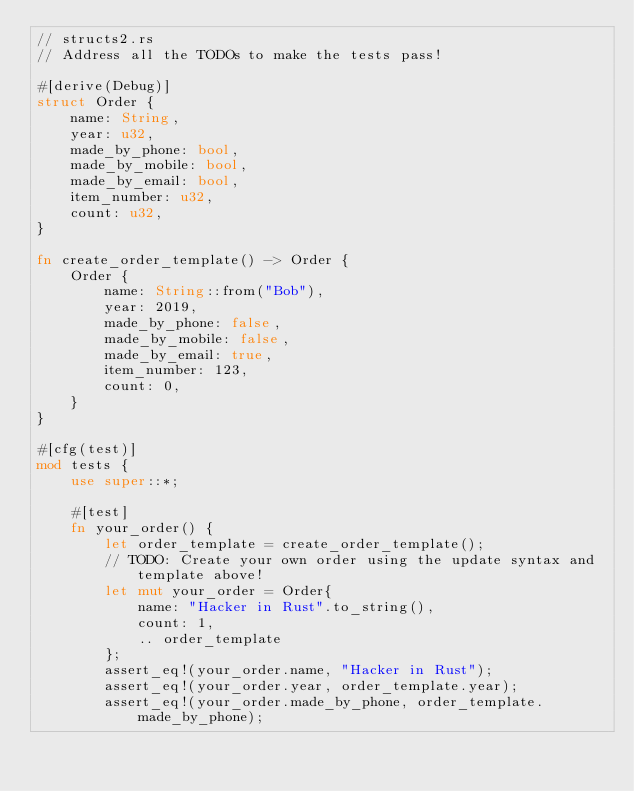<code> <loc_0><loc_0><loc_500><loc_500><_Rust_>// structs2.rs
// Address all the TODOs to make the tests pass!

#[derive(Debug)]
struct Order {
    name: String,
    year: u32,
    made_by_phone: bool,
    made_by_mobile: bool,
    made_by_email: bool,
    item_number: u32,
    count: u32,
}

fn create_order_template() -> Order {
    Order {
        name: String::from("Bob"),
        year: 2019,
        made_by_phone: false,
        made_by_mobile: false,
        made_by_email: true,
        item_number: 123,
        count: 0,
    }
}

#[cfg(test)]
mod tests {
    use super::*;

    #[test]
    fn your_order() {
        let order_template = create_order_template();
        // TODO: Create your own order using the update syntax and template above!
        let mut your_order = Order{
            name: "Hacker in Rust".to_string(),
            count: 1,
            .. order_template
        };
        assert_eq!(your_order.name, "Hacker in Rust");
        assert_eq!(your_order.year, order_template.year);
        assert_eq!(your_order.made_by_phone, order_template.made_by_phone);</code> 